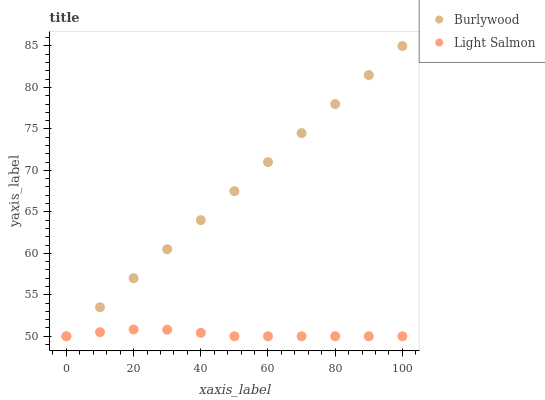Does Light Salmon have the minimum area under the curve?
Answer yes or no. Yes. Does Burlywood have the maximum area under the curve?
Answer yes or no. Yes. Does Light Salmon have the maximum area under the curve?
Answer yes or no. No. Is Burlywood the smoothest?
Answer yes or no. Yes. Is Light Salmon the roughest?
Answer yes or no. Yes. Is Light Salmon the smoothest?
Answer yes or no. No. Does Burlywood have the lowest value?
Answer yes or no. Yes. Does Burlywood have the highest value?
Answer yes or no. Yes. Does Light Salmon have the highest value?
Answer yes or no. No. Does Burlywood intersect Light Salmon?
Answer yes or no. Yes. Is Burlywood less than Light Salmon?
Answer yes or no. No. Is Burlywood greater than Light Salmon?
Answer yes or no. No. 